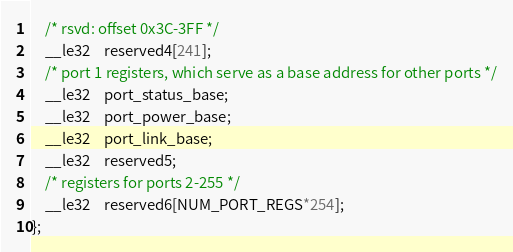<code> <loc_0><loc_0><loc_500><loc_500><_C_>	/* rsvd: offset 0x3C-3FF */
	__le32	reserved4[241];
	/* port 1 registers, which serve as a base address for other ports */
	__le32	port_status_base;
	__le32	port_power_base;
	__le32	port_link_base;
	__le32	reserved5;
	/* registers for ports 2-255 */
	__le32	reserved6[NUM_PORT_REGS*254];
};
</code> 